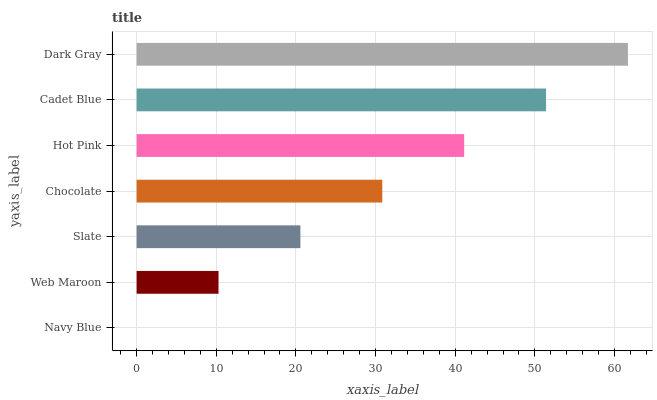Is Navy Blue the minimum?
Answer yes or no. Yes. Is Dark Gray the maximum?
Answer yes or no. Yes. Is Web Maroon the minimum?
Answer yes or no. No. Is Web Maroon the maximum?
Answer yes or no. No. Is Web Maroon greater than Navy Blue?
Answer yes or no. Yes. Is Navy Blue less than Web Maroon?
Answer yes or no. Yes. Is Navy Blue greater than Web Maroon?
Answer yes or no. No. Is Web Maroon less than Navy Blue?
Answer yes or no. No. Is Chocolate the high median?
Answer yes or no. Yes. Is Chocolate the low median?
Answer yes or no. Yes. Is Slate the high median?
Answer yes or no. No. Is Navy Blue the low median?
Answer yes or no. No. 